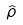Convert formula to latex. <formula><loc_0><loc_0><loc_500><loc_500>\hat { \rho }</formula> 